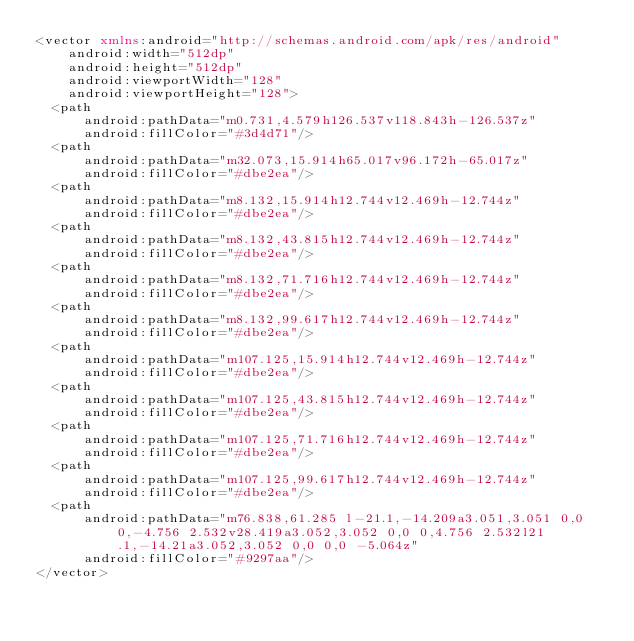<code> <loc_0><loc_0><loc_500><loc_500><_XML_><vector xmlns:android="http://schemas.android.com/apk/res/android"
    android:width="512dp"
    android:height="512dp"
    android:viewportWidth="128"
    android:viewportHeight="128">
  <path
      android:pathData="m0.731,4.579h126.537v118.843h-126.537z"
      android:fillColor="#3d4d71"/>
  <path
      android:pathData="m32.073,15.914h65.017v96.172h-65.017z"
      android:fillColor="#dbe2ea"/>
  <path
      android:pathData="m8.132,15.914h12.744v12.469h-12.744z"
      android:fillColor="#dbe2ea"/>
  <path
      android:pathData="m8.132,43.815h12.744v12.469h-12.744z"
      android:fillColor="#dbe2ea"/>
  <path
      android:pathData="m8.132,71.716h12.744v12.469h-12.744z"
      android:fillColor="#dbe2ea"/>
  <path
      android:pathData="m8.132,99.617h12.744v12.469h-12.744z"
      android:fillColor="#dbe2ea"/>
  <path
      android:pathData="m107.125,15.914h12.744v12.469h-12.744z"
      android:fillColor="#dbe2ea"/>
  <path
      android:pathData="m107.125,43.815h12.744v12.469h-12.744z"
      android:fillColor="#dbe2ea"/>
  <path
      android:pathData="m107.125,71.716h12.744v12.469h-12.744z"
      android:fillColor="#dbe2ea"/>
  <path
      android:pathData="m107.125,99.617h12.744v12.469h-12.744z"
      android:fillColor="#dbe2ea"/>
  <path
      android:pathData="m76.838,61.285 l-21.1,-14.209a3.051,3.051 0,0 0,-4.756 2.532v28.419a3.052,3.052 0,0 0,4.756 2.532l21.1,-14.21a3.052,3.052 0,0 0,0 -5.064z"
      android:fillColor="#9297aa"/>
</vector>
</code> 